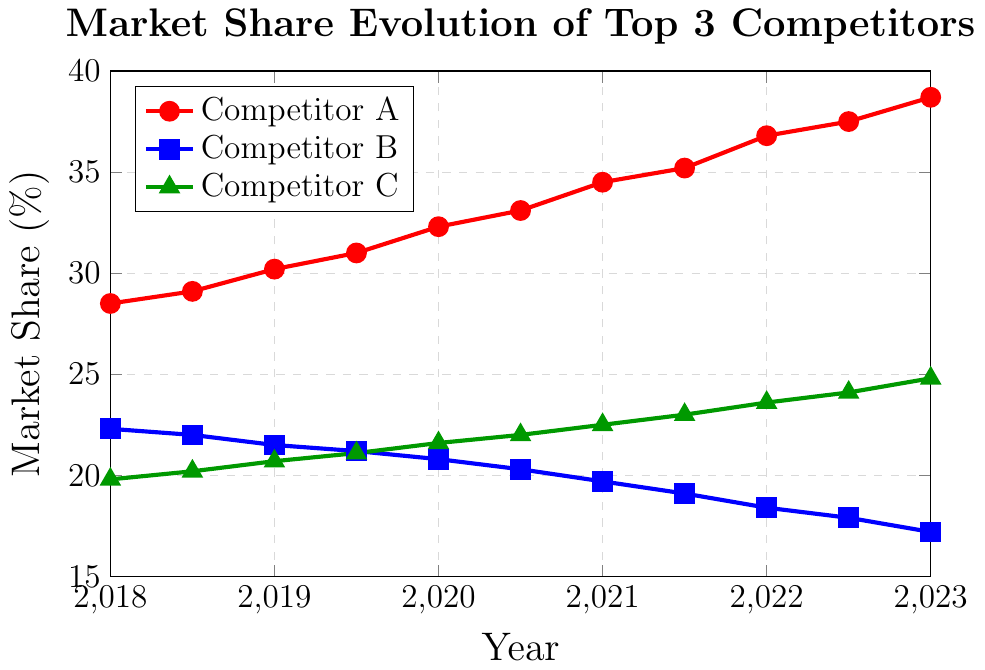What is the overall trend of Competitor A's market share from 2018 to 2023? To determine the trend, observe the red line representing Competitor A on the graph. From 2018 to 2023, the line consistently moves upward, indicating a positive trend.
Answer: Increasing Which competitor had the highest market share in 2023? Look at the data points for 2023 and compare the heights of the markers for each competitor. The highest marker for 2023 is for Competitor A (red line) at 38.7%.
Answer: Competitor A Between 2018 and 2023, what was the maximum market share achieved by Competitor C? To find the maximum market share for Competitor C, observe the green line and identify the highest point. The highest point is in 2023 at 24.8%.
Answer: 24.8% Compare the market share of Competitor B and Competitor C in 2020. Which one had a higher market share? Look at the points for 2020 for both Competitor B (blue line) and Competitor C (green line). Competitor C had a market share of 21.6%, which is higher than Competitor B's 20.8%.
Answer: Competitor C How much did Competitor A's market share increase from 2018 to 2023? Subtract the market share of Competitor A in 2018 (28.5%) from its market share in 2023 (38.7%) to get the increase. 38.7% - 28.5% = 10.2%.
Answer: 10.2% What is the trend of Competitor B's market share between 2018 and 2023? Observe the blue line representing Competitor B on the graph. The line consistently moves downward from 2018 to 2023.
Answer: Decreasing In 2021, how much more market share did Competitor A have compared to Competitor B? Find the market share of Competitor A (34.5%) and Competitor B (19.7%) in 2021. Subtract the market share of Competitor B from Competitor A: 34.5% - 19.7% = 14.8%.
Answer: 14.8% What is the average market share of Competitor C over the period from 2018 to 2023? To calculate the average, sum the market shares of Competitor C at all data points and divide by the number of data points. (19.8 + 20.2 + 20.7 + 21.1 + 21.6 + 22.0 + 22.5 + 23.0 + 23.6 + 24.1 + 24.8) / 11 = 22.04%.
Answer: 22.04% Which competitor had the steepest increase in market share between any two consecutive years? To identify the steepest increase, observe the slopes between consecutive points for each competitor. The steepest increase occurs for Competitor C between 2022.5 and 2023, where the market share increased from 24.1% to 24.8%, an increase of 0.7%.
Answer: Competitor C Did any competitor have a constant market share over any period? Observing the lines in the graph, none of the competitors have a segment where the market share remains unchanged (a perfectly horizontal line). All competitors show varying market shares over the years.
Answer: No 